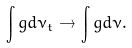Convert formula to latex. <formula><loc_0><loc_0><loc_500><loc_500>\int g d \nu _ { t } \to \int g d \nu .</formula> 